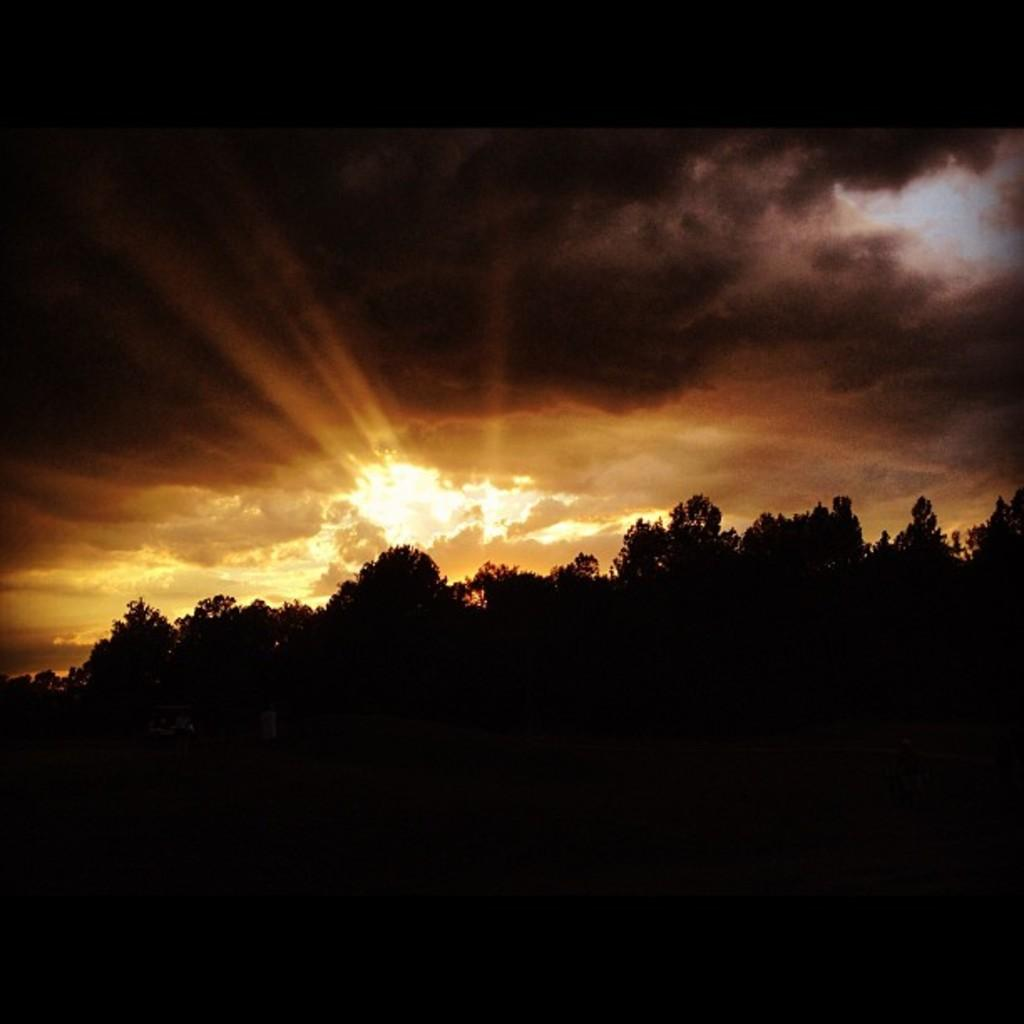What is the overall lighting condition of the image? The image is dark. What type of natural elements can be seen in the image? There are trees visible in the image. What part of the natural environment is visible in the image? The sky is visible in the image. What is the condition of the sky in the image? Clouds are present in the sky. What type of wire is being used to express anger in the image? There is no wire or expression of anger present in the image. 